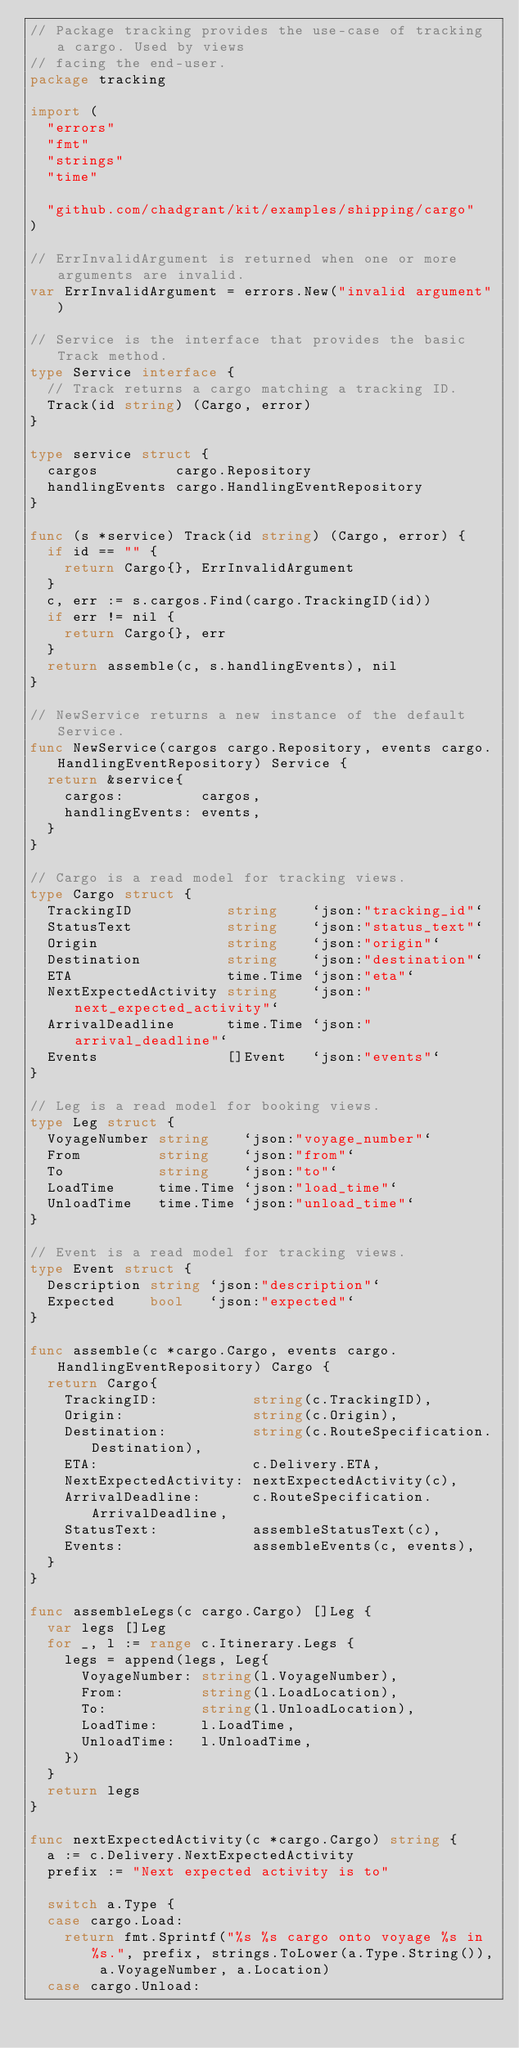<code> <loc_0><loc_0><loc_500><loc_500><_Go_>// Package tracking provides the use-case of tracking a cargo. Used by views
// facing the end-user.
package tracking

import (
	"errors"
	"fmt"
	"strings"
	"time"

	"github.com/chadgrant/kit/examples/shipping/cargo"
)

// ErrInvalidArgument is returned when one or more arguments are invalid.
var ErrInvalidArgument = errors.New("invalid argument")

// Service is the interface that provides the basic Track method.
type Service interface {
	// Track returns a cargo matching a tracking ID.
	Track(id string) (Cargo, error)
}

type service struct {
	cargos         cargo.Repository
	handlingEvents cargo.HandlingEventRepository
}

func (s *service) Track(id string) (Cargo, error) {
	if id == "" {
		return Cargo{}, ErrInvalidArgument
	}
	c, err := s.cargos.Find(cargo.TrackingID(id))
	if err != nil {
		return Cargo{}, err
	}
	return assemble(c, s.handlingEvents), nil
}

// NewService returns a new instance of the default Service.
func NewService(cargos cargo.Repository, events cargo.HandlingEventRepository) Service {
	return &service{
		cargos:         cargos,
		handlingEvents: events,
	}
}

// Cargo is a read model for tracking views.
type Cargo struct {
	TrackingID           string    `json:"tracking_id"`
	StatusText           string    `json:"status_text"`
	Origin               string    `json:"origin"`
	Destination          string    `json:"destination"`
	ETA                  time.Time `json:"eta"`
	NextExpectedActivity string    `json:"next_expected_activity"`
	ArrivalDeadline      time.Time `json:"arrival_deadline"`
	Events               []Event   `json:"events"`
}

// Leg is a read model for booking views.
type Leg struct {
	VoyageNumber string    `json:"voyage_number"`
	From         string    `json:"from"`
	To           string    `json:"to"`
	LoadTime     time.Time `json:"load_time"`
	UnloadTime   time.Time `json:"unload_time"`
}

// Event is a read model for tracking views.
type Event struct {
	Description string `json:"description"`
	Expected    bool   `json:"expected"`
}

func assemble(c *cargo.Cargo, events cargo.HandlingEventRepository) Cargo {
	return Cargo{
		TrackingID:           string(c.TrackingID),
		Origin:               string(c.Origin),
		Destination:          string(c.RouteSpecification.Destination),
		ETA:                  c.Delivery.ETA,
		NextExpectedActivity: nextExpectedActivity(c),
		ArrivalDeadline:      c.RouteSpecification.ArrivalDeadline,
		StatusText:           assembleStatusText(c),
		Events:               assembleEvents(c, events),
	}
}

func assembleLegs(c cargo.Cargo) []Leg {
	var legs []Leg
	for _, l := range c.Itinerary.Legs {
		legs = append(legs, Leg{
			VoyageNumber: string(l.VoyageNumber),
			From:         string(l.LoadLocation),
			To:           string(l.UnloadLocation),
			LoadTime:     l.LoadTime,
			UnloadTime:   l.UnloadTime,
		})
	}
	return legs
}

func nextExpectedActivity(c *cargo.Cargo) string {
	a := c.Delivery.NextExpectedActivity
	prefix := "Next expected activity is to"

	switch a.Type {
	case cargo.Load:
		return fmt.Sprintf("%s %s cargo onto voyage %s in %s.", prefix, strings.ToLower(a.Type.String()), a.VoyageNumber, a.Location)
	case cargo.Unload:</code> 